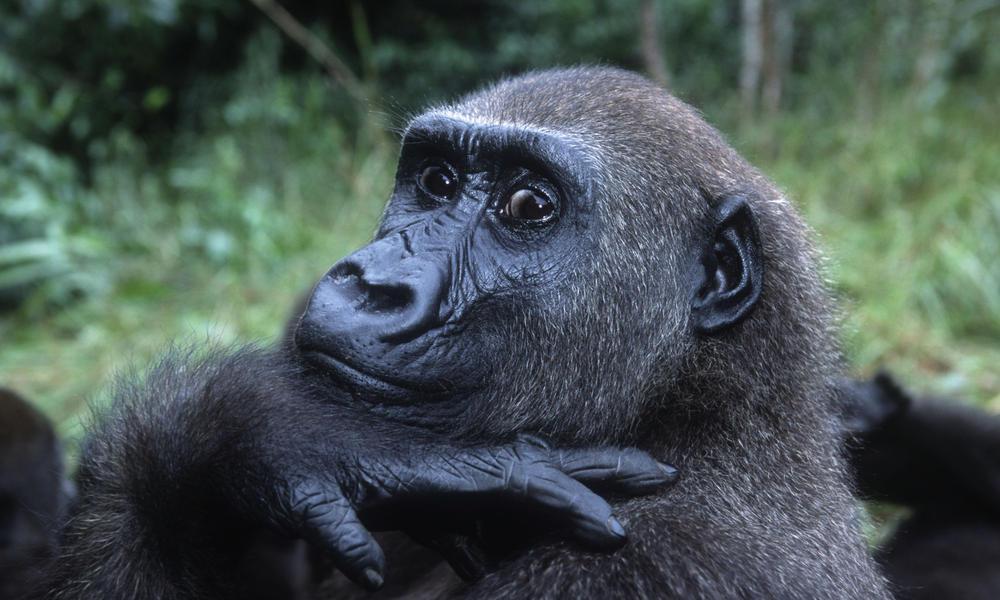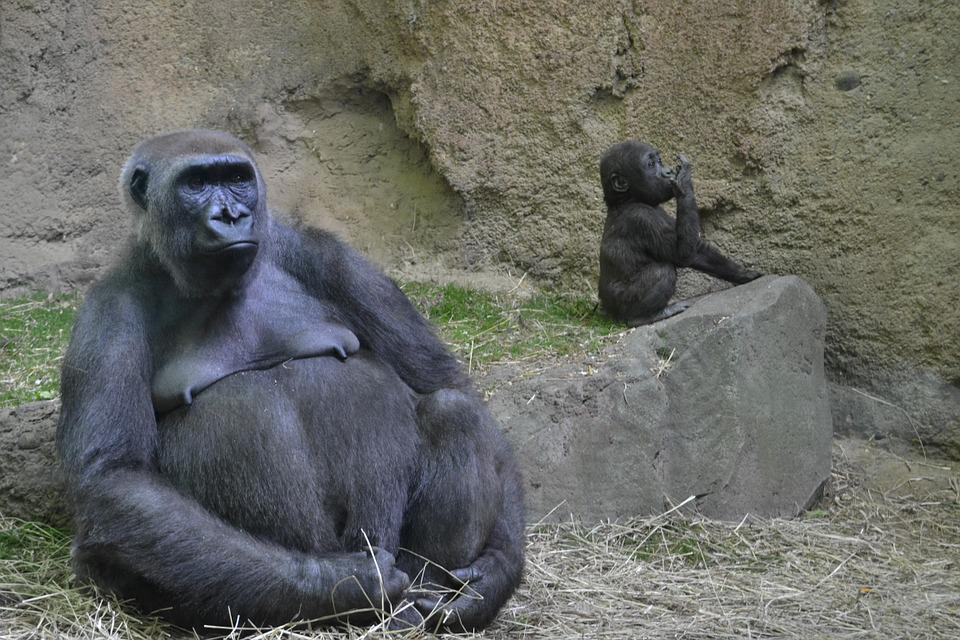The first image is the image on the left, the second image is the image on the right. Considering the images on both sides, is "The nipples are hanging down on an adult primate in the image on the right." valid? Answer yes or no. Yes. The first image is the image on the left, the second image is the image on the right. Considering the images on both sides, is "A baby gorilla is holding onto an adult in an image with only two gorillas." valid? Answer yes or no. No. 